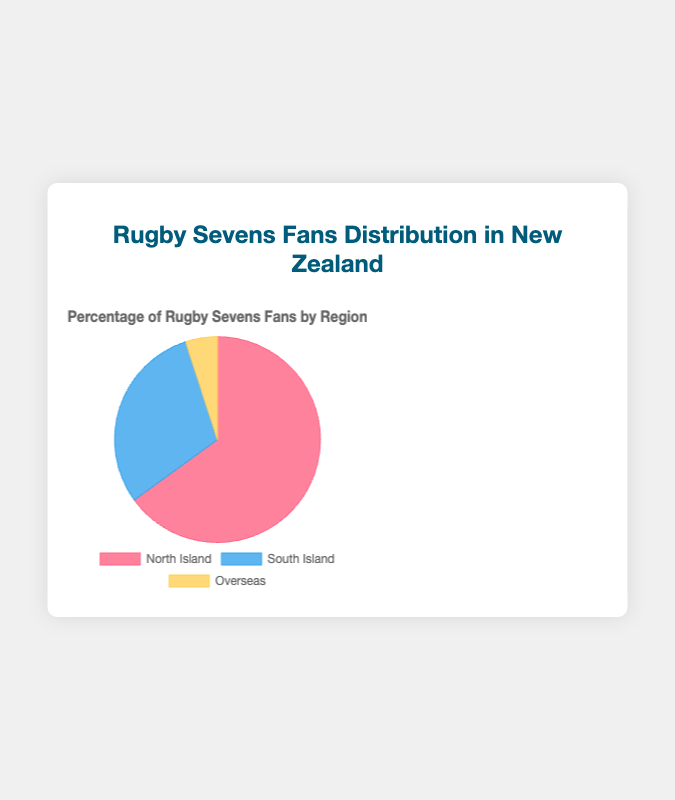What percentage of rugby sevens fans are from the North Island? The figure shows that 65% of rugby sevens fans are from the North Island.
Answer: 65% Which region has the smallest percentage of rugby sevens fans? The figure indicates that Overseas has the smallest percentage with 5%.
Answer: Overseas What is the combined percentage of rugby sevens fans from the South Island and Overseas? The South Island has 30% and Overseas has 5%. Combined, this is 30% + 5% = 35%.
Answer: 35% How does the percentage of rugby sevens fans in the North Island compare to that in the South Island? The North Island has 65% fans and the South Island has 30%. The North Island has more fans.
Answer: North Island has more What fraction of fans are from regions within New Zealand (North Island and South Island)? The North Island and South Island together have 65% + 30% = 95% fans.
Answer: 95% Which region has more rugby sevens fans, the North Island or Overseas, and by how much? The North Island has 65% and Overseas has 5%. The difference is 65% - 5% = 60%.
Answer: North Island by 60% Are there more rugby sevens fans overseas or in the South Island? The South Island has 30% fans while Overseas has 5%. There are more fans in the South Island.
Answer: South Island If you sum up the percentages of fans from all regions, what will the total be? The percentages are 65% (North Island), 30% (South Island), and 5% (Overseas). Summing them up: 65% + 30% + 5% = 100%.
Answer: 100% What percentage of rugby sevens fans come from within New Zealand? The North Island and South Island together have 65% + 30% = 95%. Therefore, 95% of fans are from within New Zealand.
Answer: 95% 